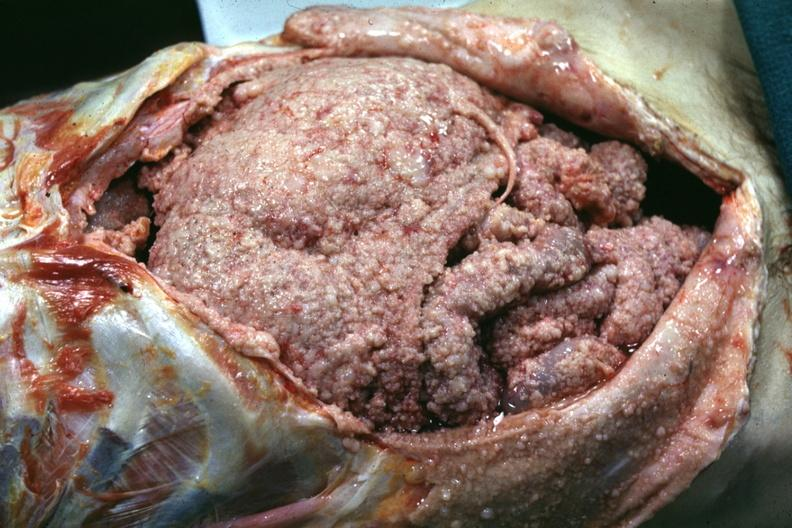s mesothelioma present?
Answer the question using a single word or phrase. Yes 